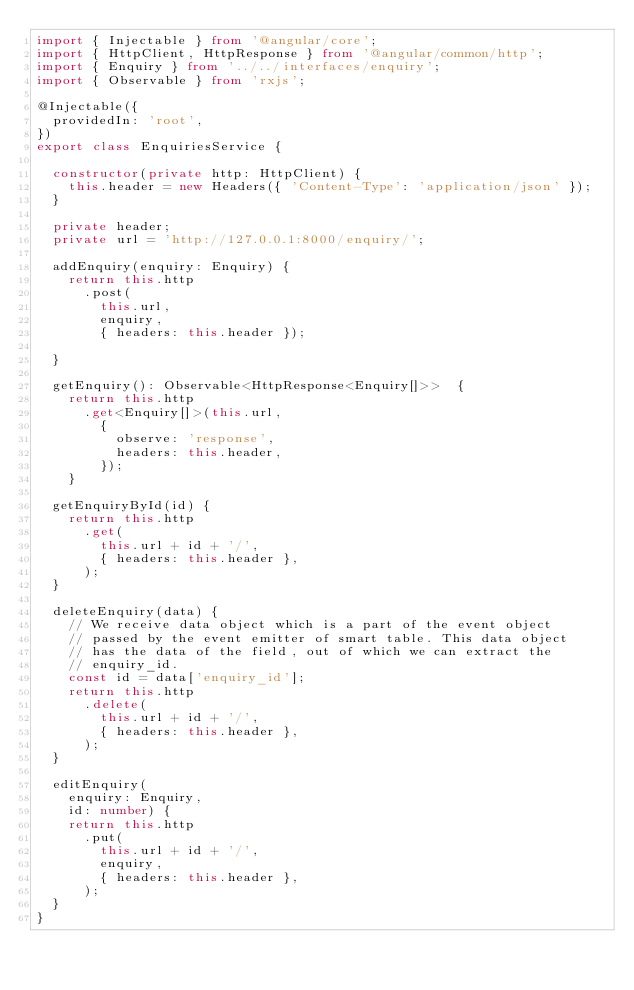Convert code to text. <code><loc_0><loc_0><loc_500><loc_500><_TypeScript_>import { Injectable } from '@angular/core';
import { HttpClient, HttpResponse } from '@angular/common/http';
import { Enquiry } from '../../interfaces/enquiry';
import { Observable } from 'rxjs';

@Injectable({
  providedIn: 'root',
})
export class EnquiriesService {

  constructor(private http: HttpClient) {
    this.header = new Headers({ 'Content-Type': 'application/json' });
  }

  private header;
  private url = 'http://127.0.0.1:8000/enquiry/';

  addEnquiry(enquiry: Enquiry) {
    return this.http
      .post(
        this.url,
        enquiry,
        { headers: this.header });

  }

  getEnquiry(): Observable<HttpResponse<Enquiry[]>>  {
    return this.http
      .get<Enquiry[]>(this.url,
        {
          observe: 'response',
          headers: this.header,
        });
    }

  getEnquiryById(id) {
    return this.http
      .get(
        this.url + id + '/',
        { headers: this.header },
      );
  }

  deleteEnquiry(data) {
    // We receive data object which is a part of the event object
    // passed by the event emitter of smart table. This data object
    // has the data of the field, out of which we can extract the
    // enquiry_id.
    const id = data['enquiry_id'];
    return this.http
      .delete(
        this.url + id + '/',
        { headers: this.header },
      );
  }

  editEnquiry(
    enquiry: Enquiry,
    id: number) {
    return this.http
      .put(
        this.url + id + '/',
        enquiry,
        { headers: this.header },
      );
  }
}
</code> 